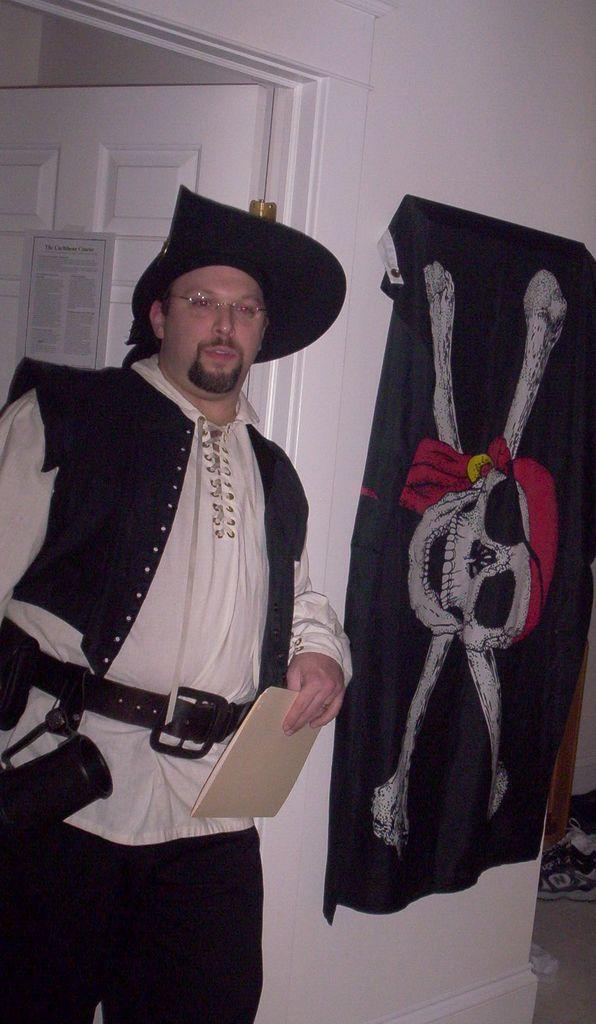In one or two sentences, can you explain what this image depicts? In this picture we can observe a person standing, wearing a black color hat on his head and spectacles. He is in a pirate costume. On the right side there is a black color flag hanged to the wall. We can observe a white color door in the background. 